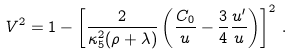Convert formula to latex. <formula><loc_0><loc_0><loc_500><loc_500>V ^ { 2 } = 1 - \left [ \frac { 2 } { \kappa _ { 5 } ^ { 2 } ( \rho + \lambda ) } \left ( \frac { C _ { 0 } } { u } - \frac { 3 } { 4 } \frac { u ^ { \prime } } { u } \right ) \right ] ^ { 2 } \, .</formula> 